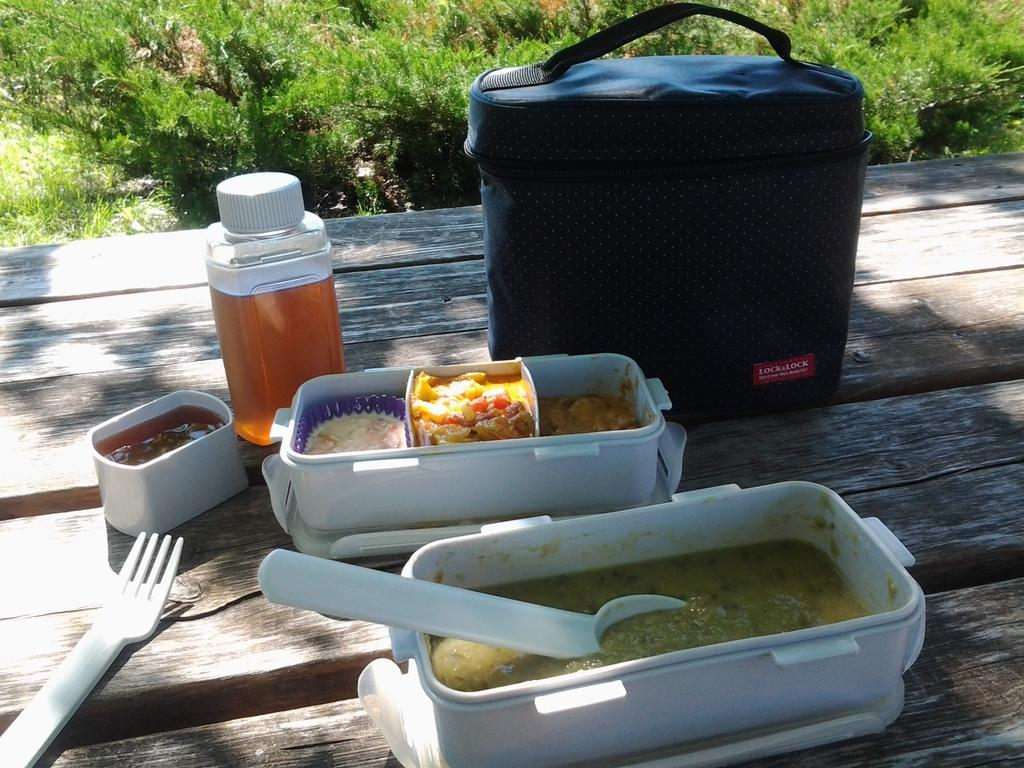Provide a one-sentence caption for the provided image. The food contents of a Lock&Lock lunch tote are spread out on the table. 